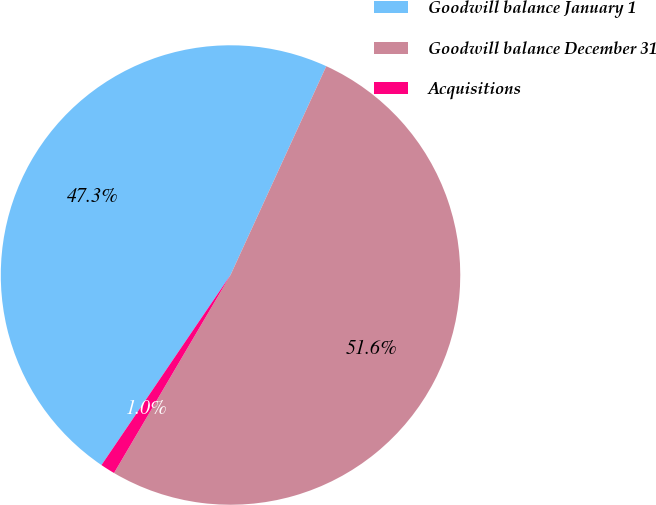Convert chart. <chart><loc_0><loc_0><loc_500><loc_500><pie_chart><fcel>Goodwill balance January 1<fcel>Goodwill balance December 31<fcel>Acquisitions<nl><fcel>47.35%<fcel>51.62%<fcel>1.03%<nl></chart> 